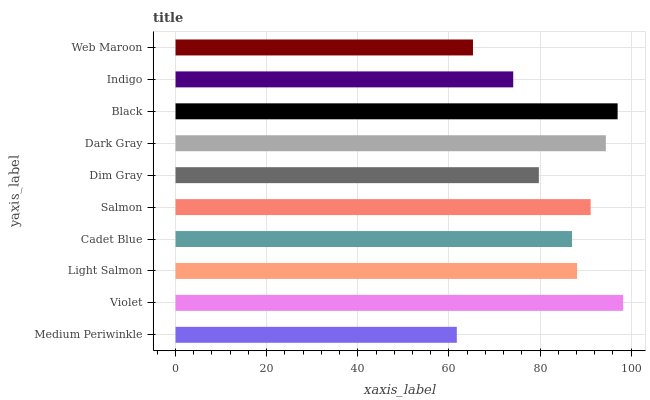Is Medium Periwinkle the minimum?
Answer yes or no. Yes. Is Violet the maximum?
Answer yes or no. Yes. Is Light Salmon the minimum?
Answer yes or no. No. Is Light Salmon the maximum?
Answer yes or no. No. Is Violet greater than Light Salmon?
Answer yes or no. Yes. Is Light Salmon less than Violet?
Answer yes or no. Yes. Is Light Salmon greater than Violet?
Answer yes or no. No. Is Violet less than Light Salmon?
Answer yes or no. No. Is Light Salmon the high median?
Answer yes or no. Yes. Is Cadet Blue the low median?
Answer yes or no. Yes. Is Dim Gray the high median?
Answer yes or no. No. Is Light Salmon the low median?
Answer yes or no. No. 